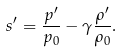Convert formula to latex. <formula><loc_0><loc_0><loc_500><loc_500>s ^ { \prime } = \frac { p ^ { \prime } } { p _ { 0 } } - \gamma \frac { \rho ^ { \prime } } { \rho _ { 0 } } .</formula> 